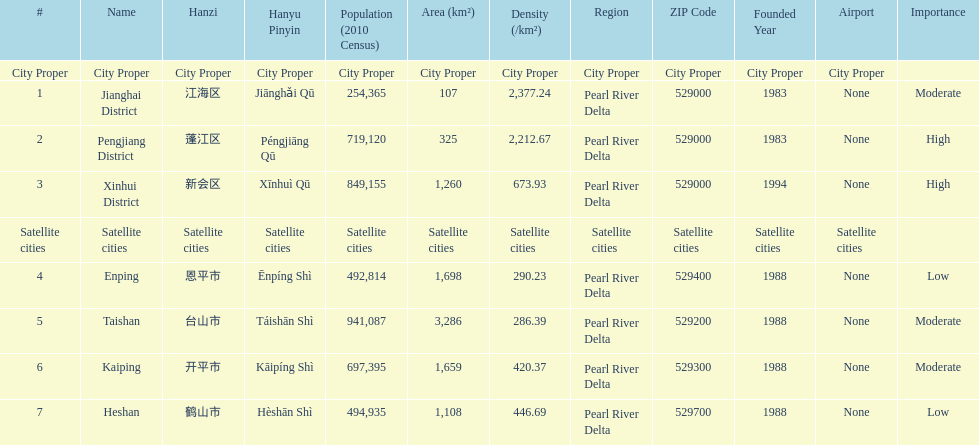Which area has the largest population? Taishan. 